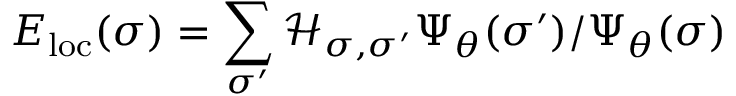<formula> <loc_0><loc_0><loc_500><loc_500>E _ { l o c } ( \sigma ) = \sum _ { \sigma ^ { \prime } } \mathcal { H } _ { \sigma , \sigma ^ { \prime } } \Psi _ { \theta } ( \sigma ^ { \prime } ) / \Psi _ { \theta } ( \sigma )</formula> 